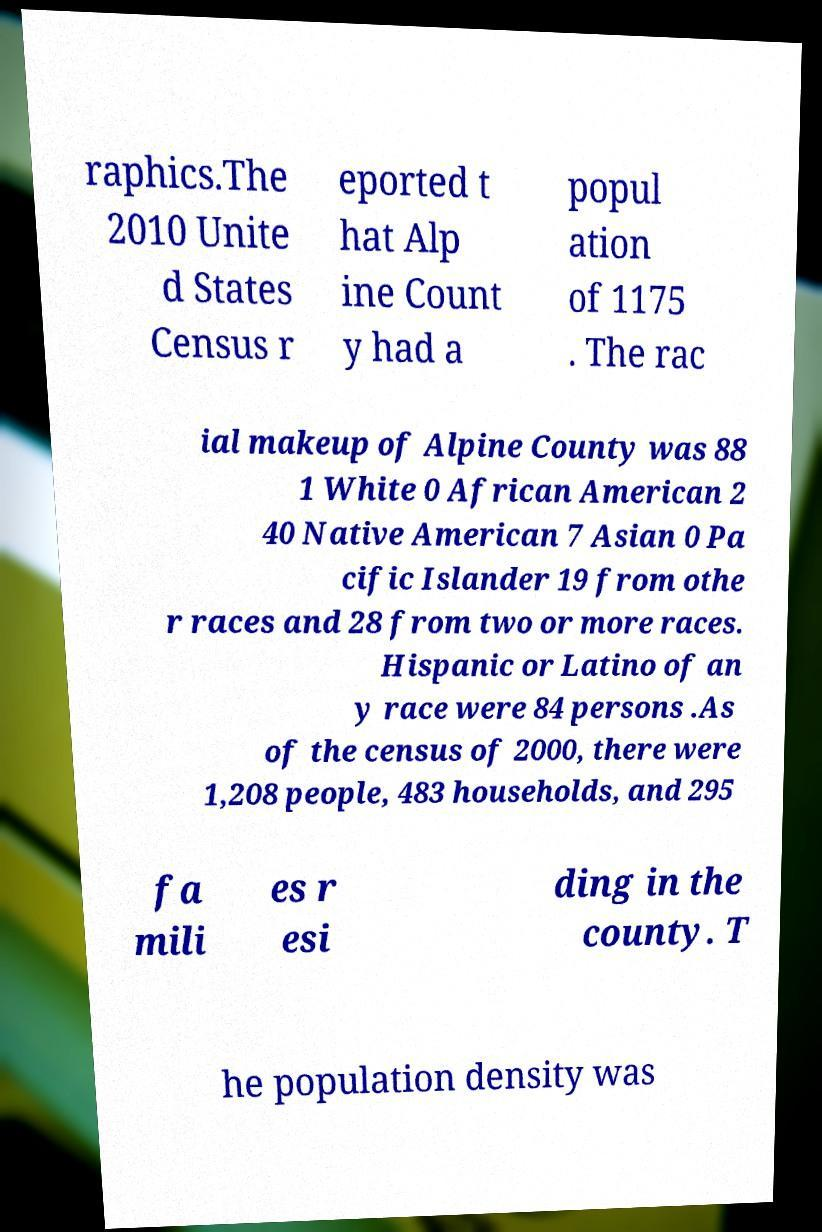Could you extract and type out the text from this image? raphics.The 2010 Unite d States Census r eported t hat Alp ine Count y had a popul ation of 1175 . The rac ial makeup of Alpine County was 88 1 White 0 African American 2 40 Native American 7 Asian 0 Pa cific Islander 19 from othe r races and 28 from two or more races. Hispanic or Latino of an y race were 84 persons .As of the census of 2000, there were 1,208 people, 483 households, and 295 fa mili es r esi ding in the county. T he population density was 